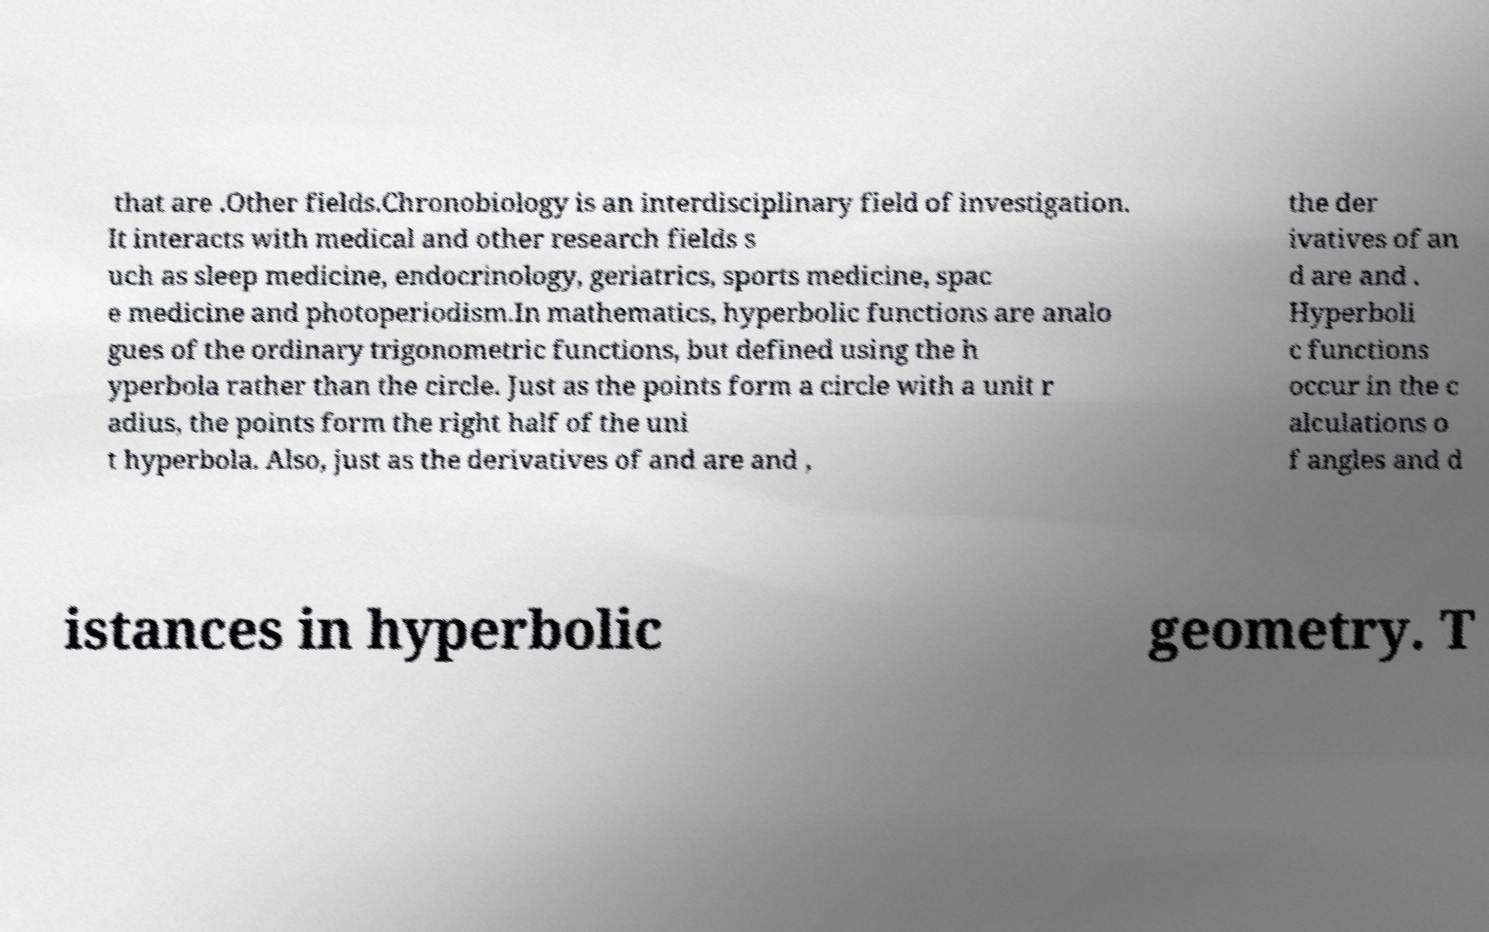What messages or text are displayed in this image? I need them in a readable, typed format. that are .Other fields.Chronobiology is an interdisciplinary field of investigation. It interacts with medical and other research fields s uch as sleep medicine, endocrinology, geriatrics, sports medicine, spac e medicine and photoperiodism.In mathematics, hyperbolic functions are analo gues of the ordinary trigonometric functions, but defined using the h yperbola rather than the circle. Just as the points form a circle with a unit r adius, the points form the right half of the uni t hyperbola. Also, just as the derivatives of and are and , the der ivatives of an d are and . Hyperboli c functions occur in the c alculations o f angles and d istances in hyperbolic geometry. T 